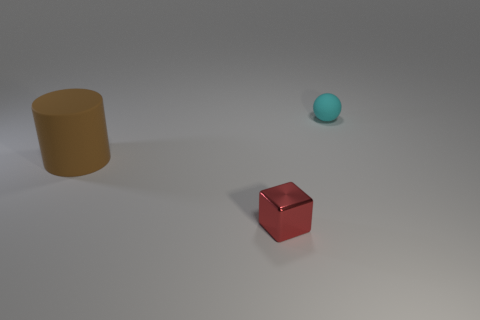There is a matte thing in front of the small cyan object; is its color the same as the small matte object?
Keep it short and to the point. No. How many cyan matte things have the same size as the brown matte object?
Your response must be concise. 0. The object that is made of the same material as the sphere is what shape?
Offer a very short reply. Cylinder. Is there another thing of the same color as the small rubber object?
Your response must be concise. No. What is the material of the cyan sphere?
Offer a very short reply. Rubber. What number of things are either cyan rubber spheres or large cyan cubes?
Offer a very short reply. 1. There is a matte object that is in front of the small cyan sphere; what is its size?
Offer a terse response. Large. What number of other things are there of the same material as the sphere
Ensure brevity in your answer.  1. There is a tiny object on the left side of the tiny matte sphere; are there any cyan matte things that are to the left of it?
Your answer should be very brief. No. Is there anything else that is the same shape as the small matte object?
Offer a very short reply. No. 